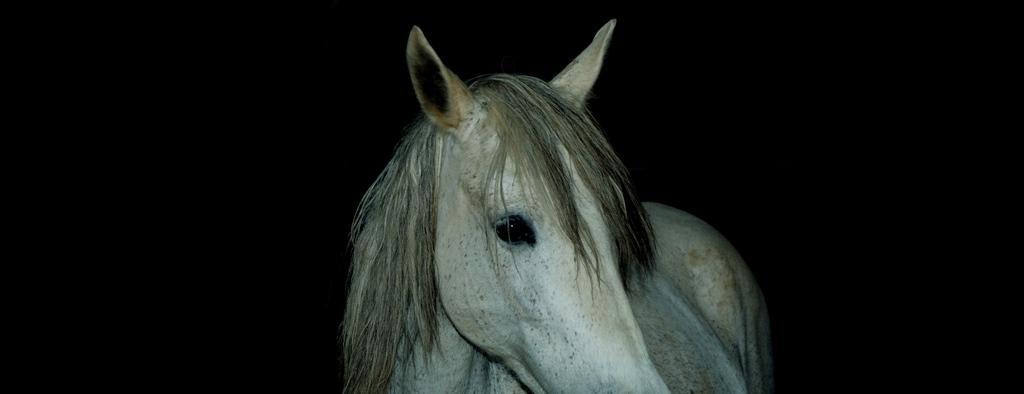Can you describe this image briefly? In this image I can see a white color horse and background is dark. 